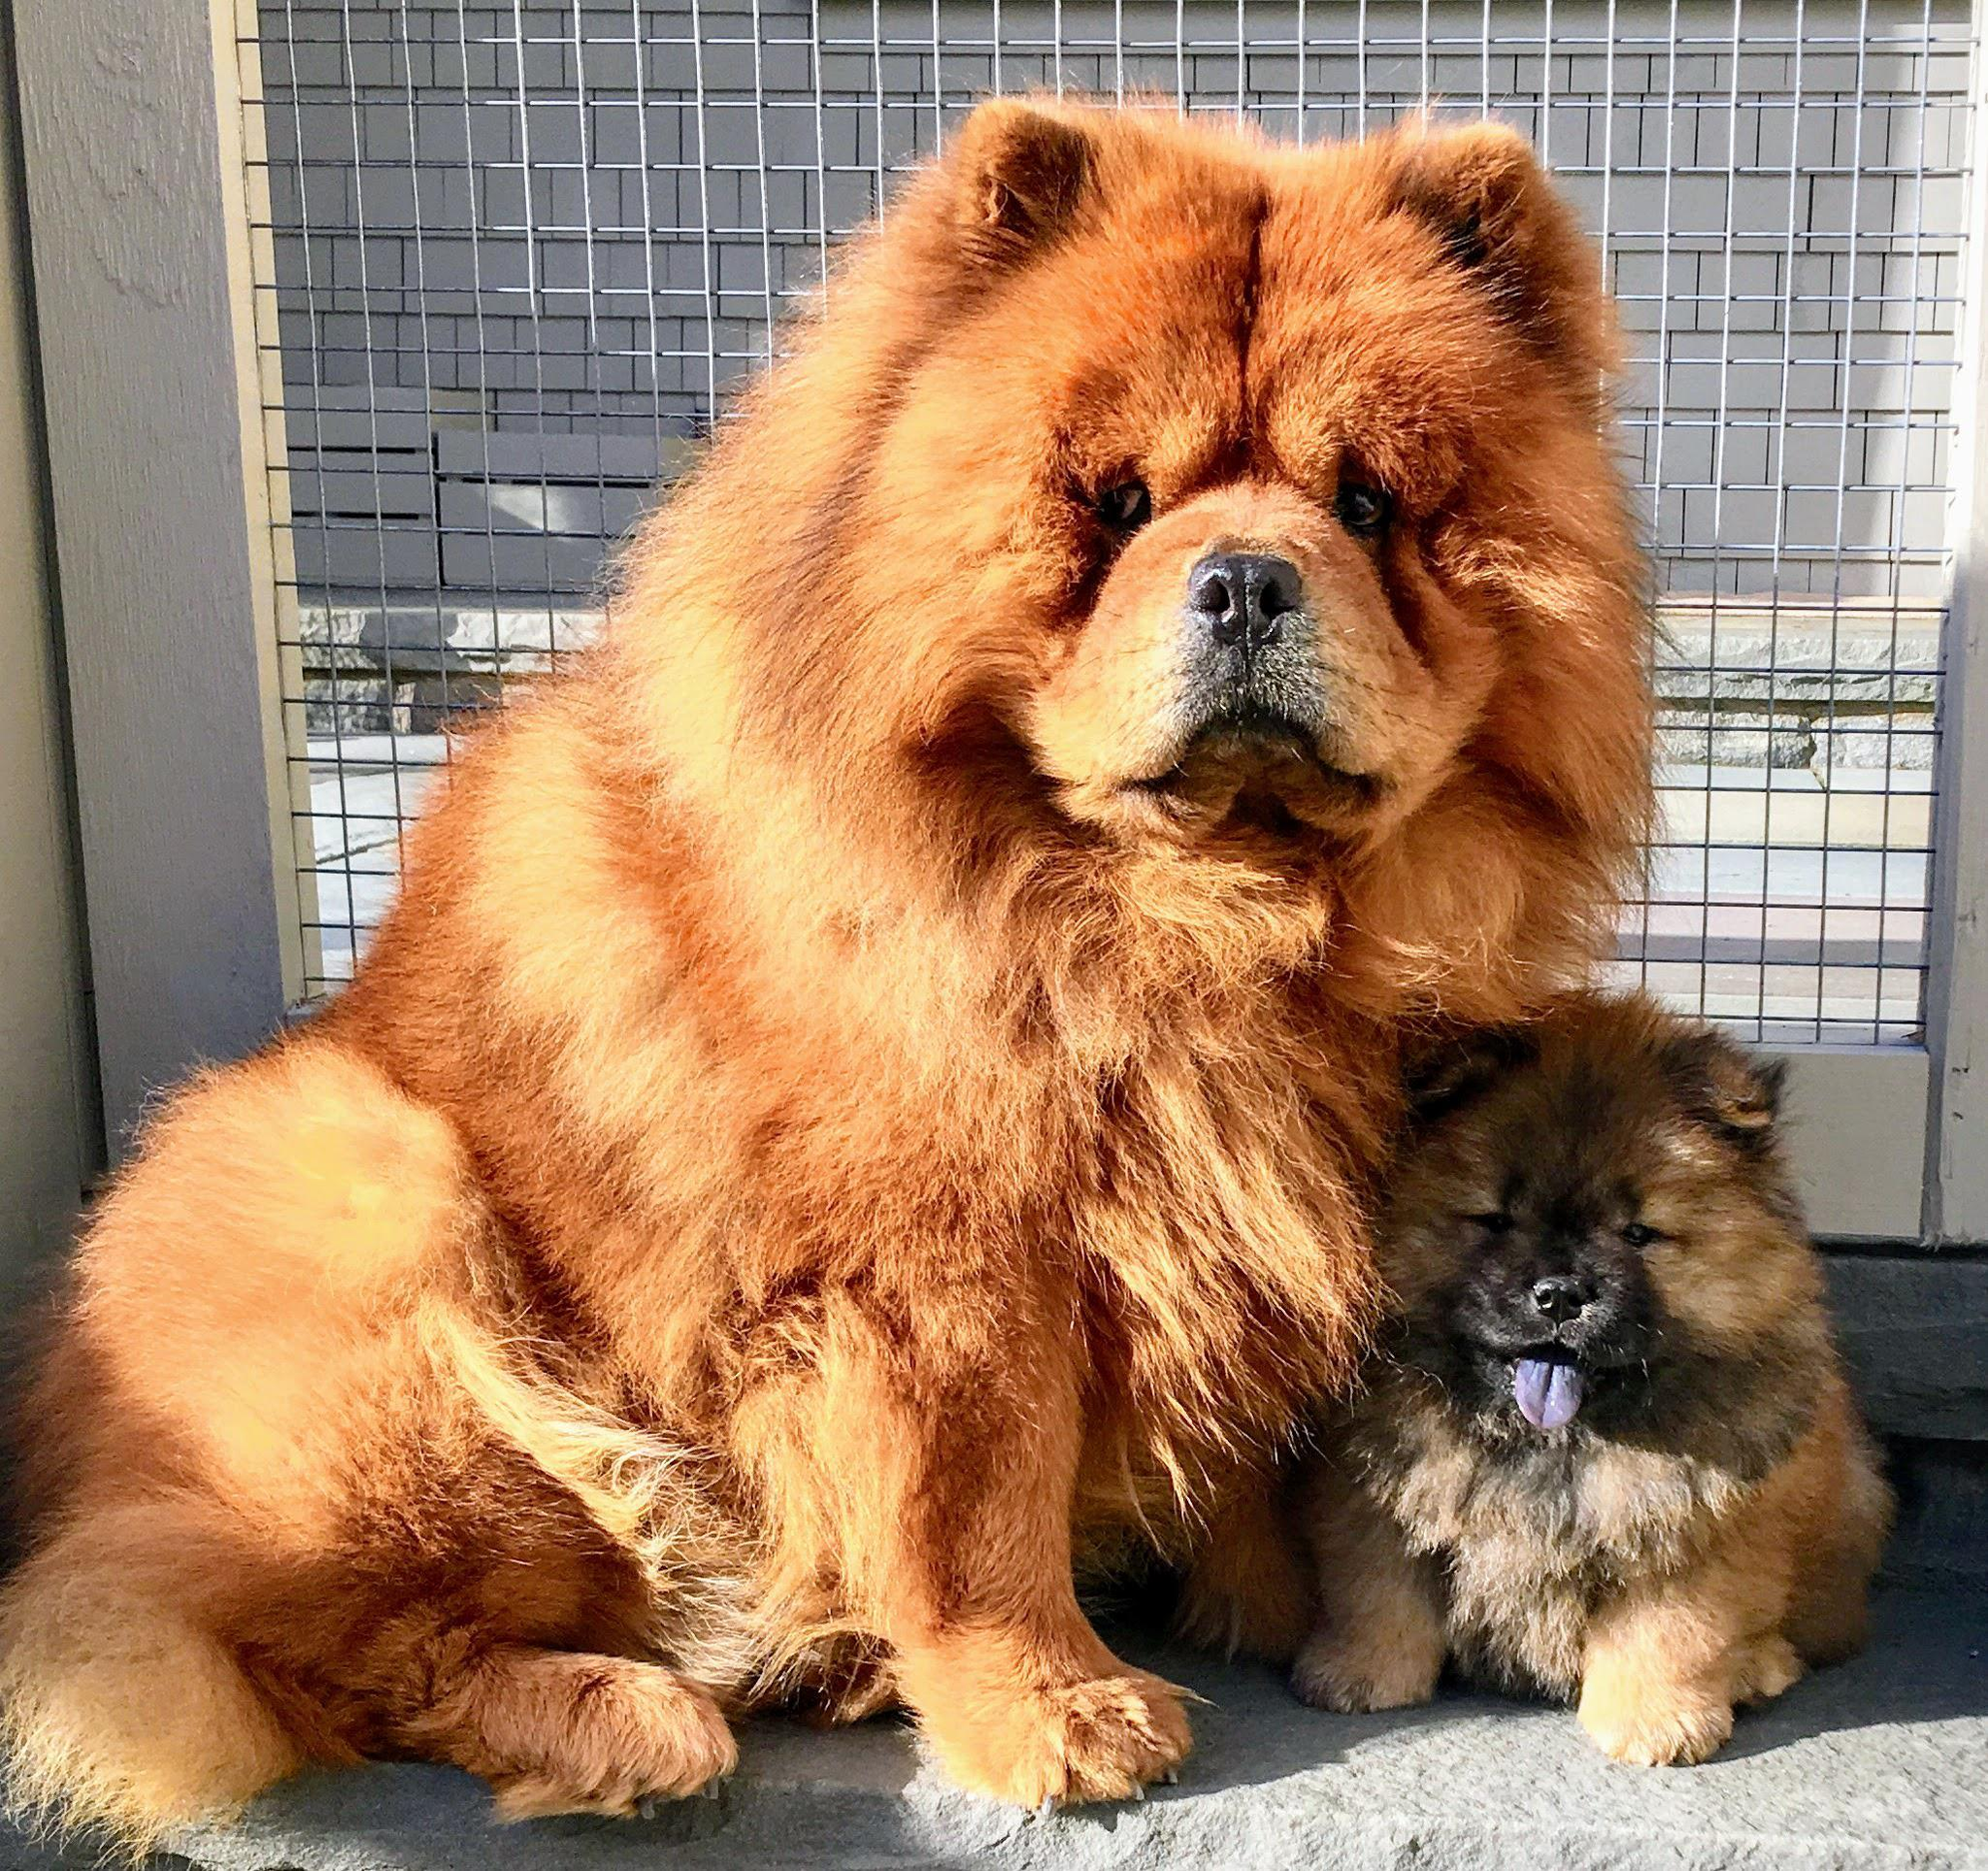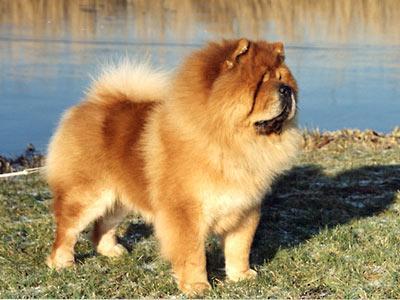The first image is the image on the left, the second image is the image on the right. For the images displayed, is the sentence "The right image contains exactly one chow whose body is facing towards the left and their face is looking at the camera." factually correct? Answer yes or no. No. The first image is the image on the left, the second image is the image on the right. Examine the images to the left and right. Is the description "There are only two brown dogs in the pair of images." accurate? Answer yes or no. No. 